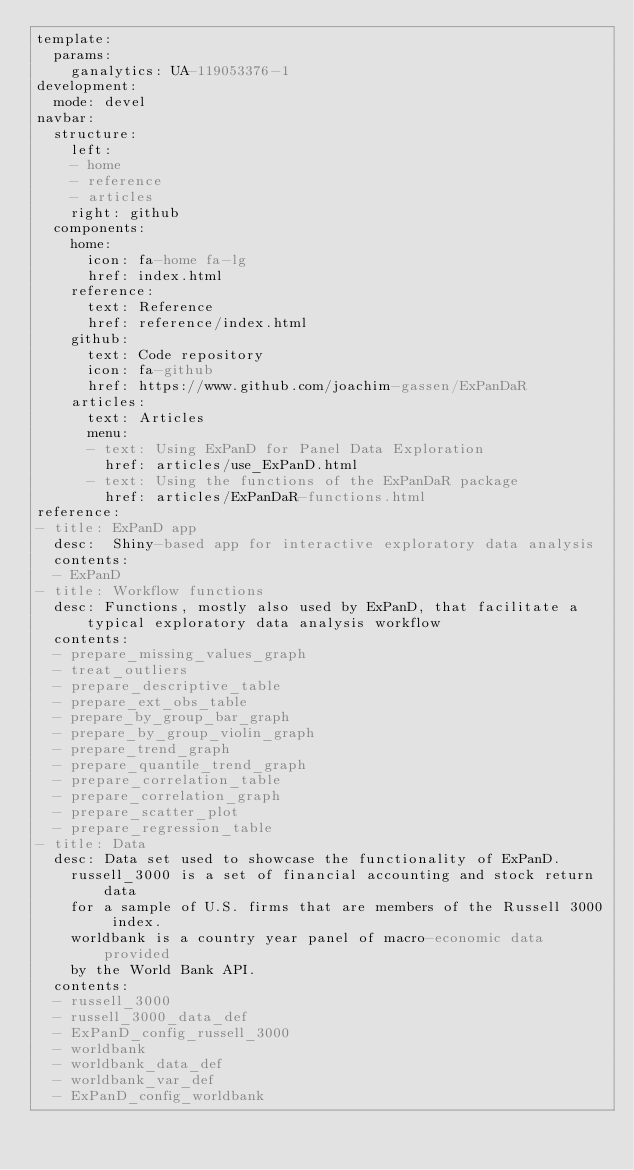Convert code to text. <code><loc_0><loc_0><loc_500><loc_500><_YAML_>template:
  params:
    ganalytics: UA-119053376-1
development:
  mode: devel
navbar:
  structure:
    left:
    - home
    - reference
    - articles
    right: github
  components:
    home:
      icon: fa-home fa-lg
      href: index.html
    reference:
      text: Reference
      href: reference/index.html
    github:
      text: Code repository
      icon: fa-github
      href: https://www.github.com/joachim-gassen/ExPanDaR
    articles:
      text: Articles
      menu:
      - text: Using ExPanD for Panel Data Exploration
        href: articles/use_ExPanD.html
      - text: Using the functions of the ExPanDaR package
        href: articles/ExPanDaR-functions.html
reference:
- title: ExPanD app
  desc:  Shiny-based app for interactive exploratory data analysis
  contents:
  - ExPanD
- title: Workflow functions
  desc: Functions, mostly also used by ExPanD, that facilitate a typical exploratory data analysis workflow
  contents:
  - prepare_missing_values_graph
  - treat_outliers
  - prepare_descriptive_table
  - prepare_ext_obs_table
  - prepare_by_group_bar_graph
  - prepare_by_group_violin_graph
  - prepare_trend_graph
  - prepare_quantile_trend_graph
  - prepare_correlation_table
  - prepare_correlation_graph
  - prepare_scatter_plot
  - prepare_regression_table
- title: Data
  desc: Data set used to showcase the functionality of ExPanD.
    russell_3000 is a set of financial accounting and stock return data
    for a sample of U.S. firms that are members of the Russell 3000 index.
    worldbank is a country year panel of macro-economic data provided
    by the World Bank API.
  contents:
  - russell_3000
  - russell_3000_data_def
  - ExPanD_config_russell_3000
  - worldbank
  - worldbank_data_def
  - worldbank_var_def
  - ExPanD_config_worldbank

</code> 